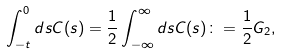<formula> <loc_0><loc_0><loc_500><loc_500>\int _ { - t } ^ { 0 } d s C ( s ) = \frac { 1 } { 2 } \int _ { - \infty } ^ { \infty } d s C ( s ) \colon = \frac { 1 } { 2 } G _ { 2 } ,</formula> 